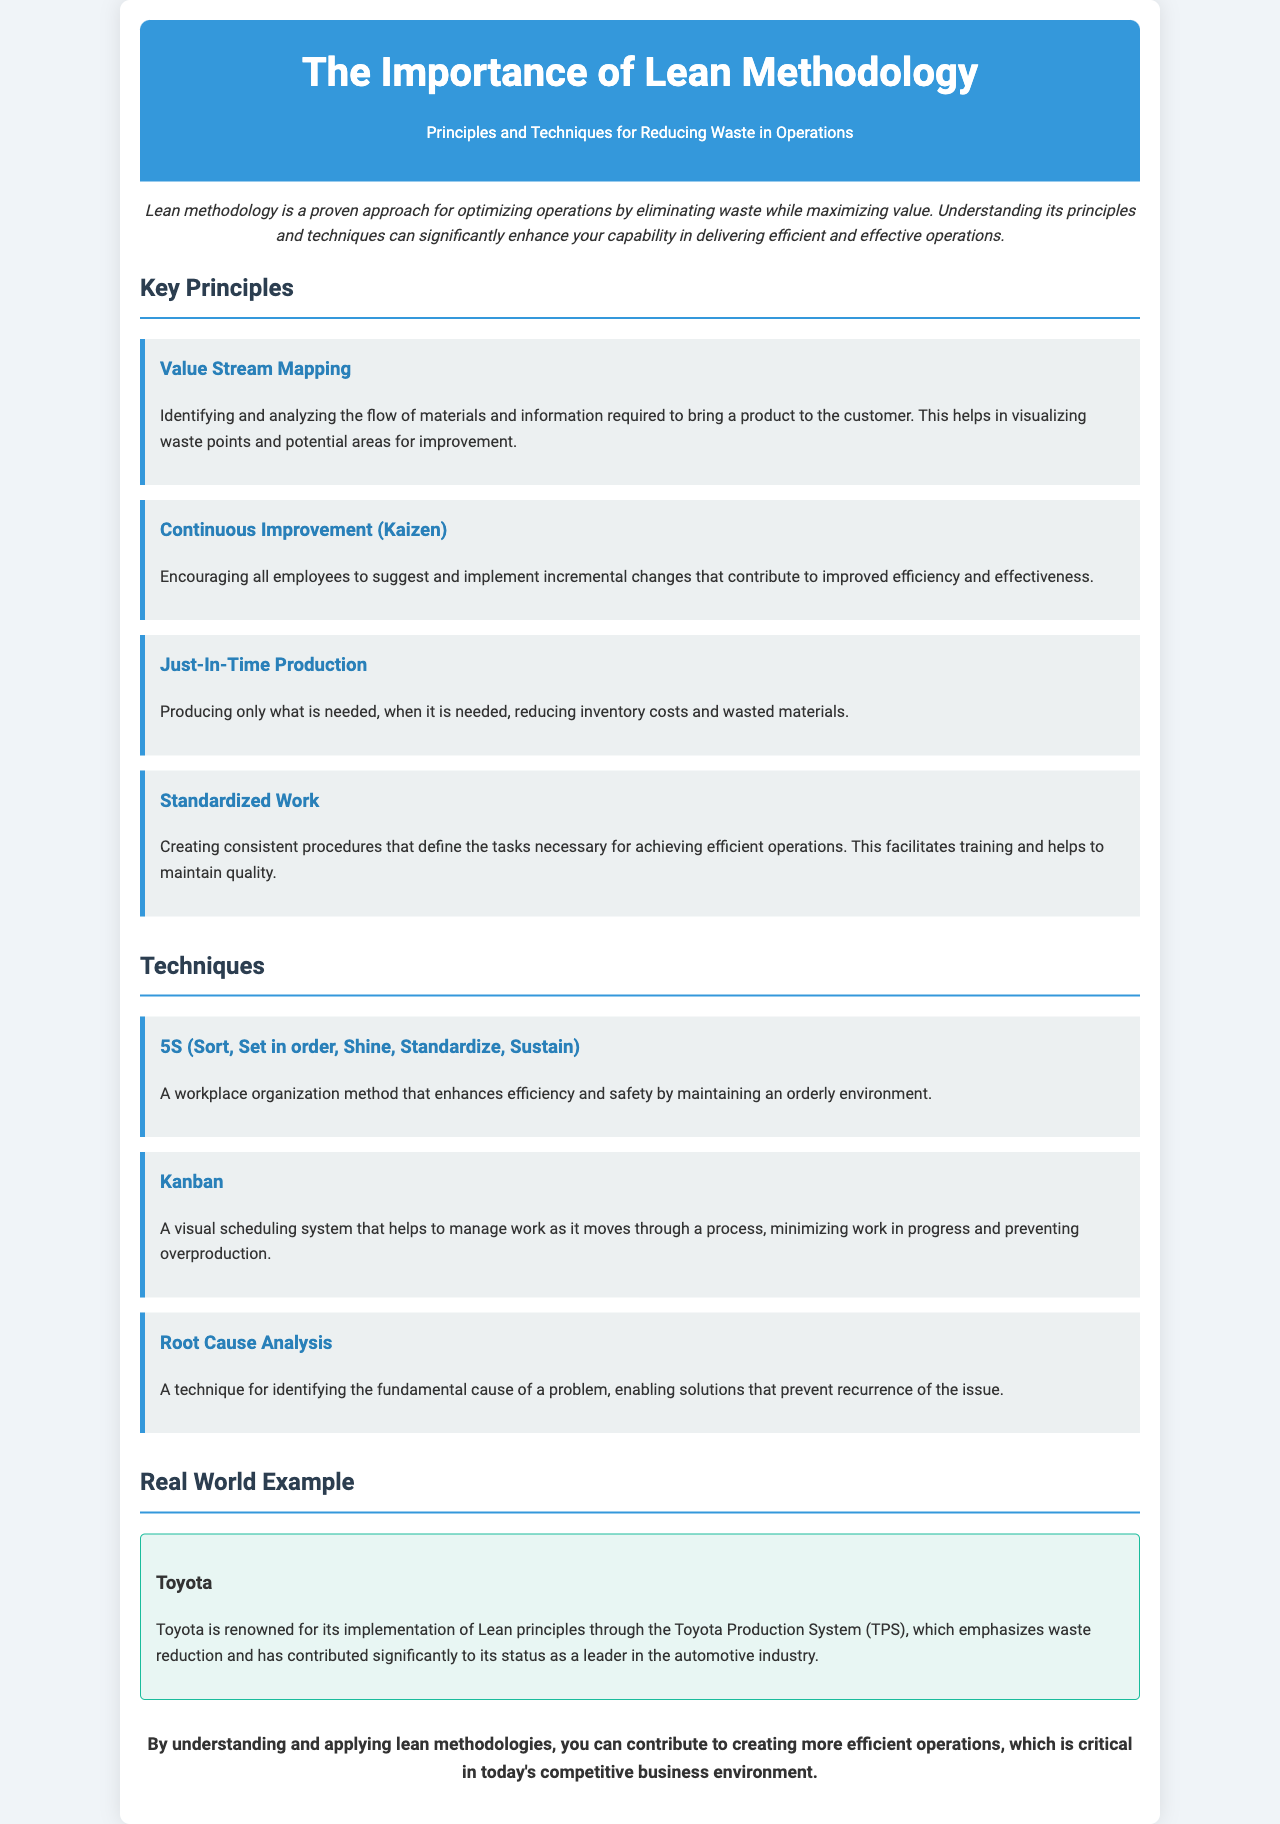What is the title of the brochure? The title is presented at the top of the document within the header section.
Answer: The Importance of Lean Methodology What is the first key principle mentioned? The principles are listed in a specific order, starting with the first principle in the Key Principles section.
Answer: Value Stream Mapping What does 5S stand for? The 5S technique is described in the Techniques section, where its components are listed.
Answer: Sort, Set in order, Shine, Standardize, Sustain Which company is given as a real-world example? The example is mentioned in the Real World Example section highlighting a well-known organization.
Answer: Toyota What is the goal of Just-In-Time Production? The explanation of Just-In-Time Production outlines its primary goal in the Principles section.
Answer: Reducing inventory costs and wasted materials How does Lean methodology enhance operations? The introduction discusses the overall impact of Lean methodology on operations.
Answer: By eliminating waste while maximizing value What method does Kanban utilize? The description of Kanban in the Techniques section explains its operational method.
Answer: A visual scheduling system What production system is Toyota known for? The real-world example mentions a specific system associated with Toyota’s approach.
Answer: Toyota Production System (TPS) 